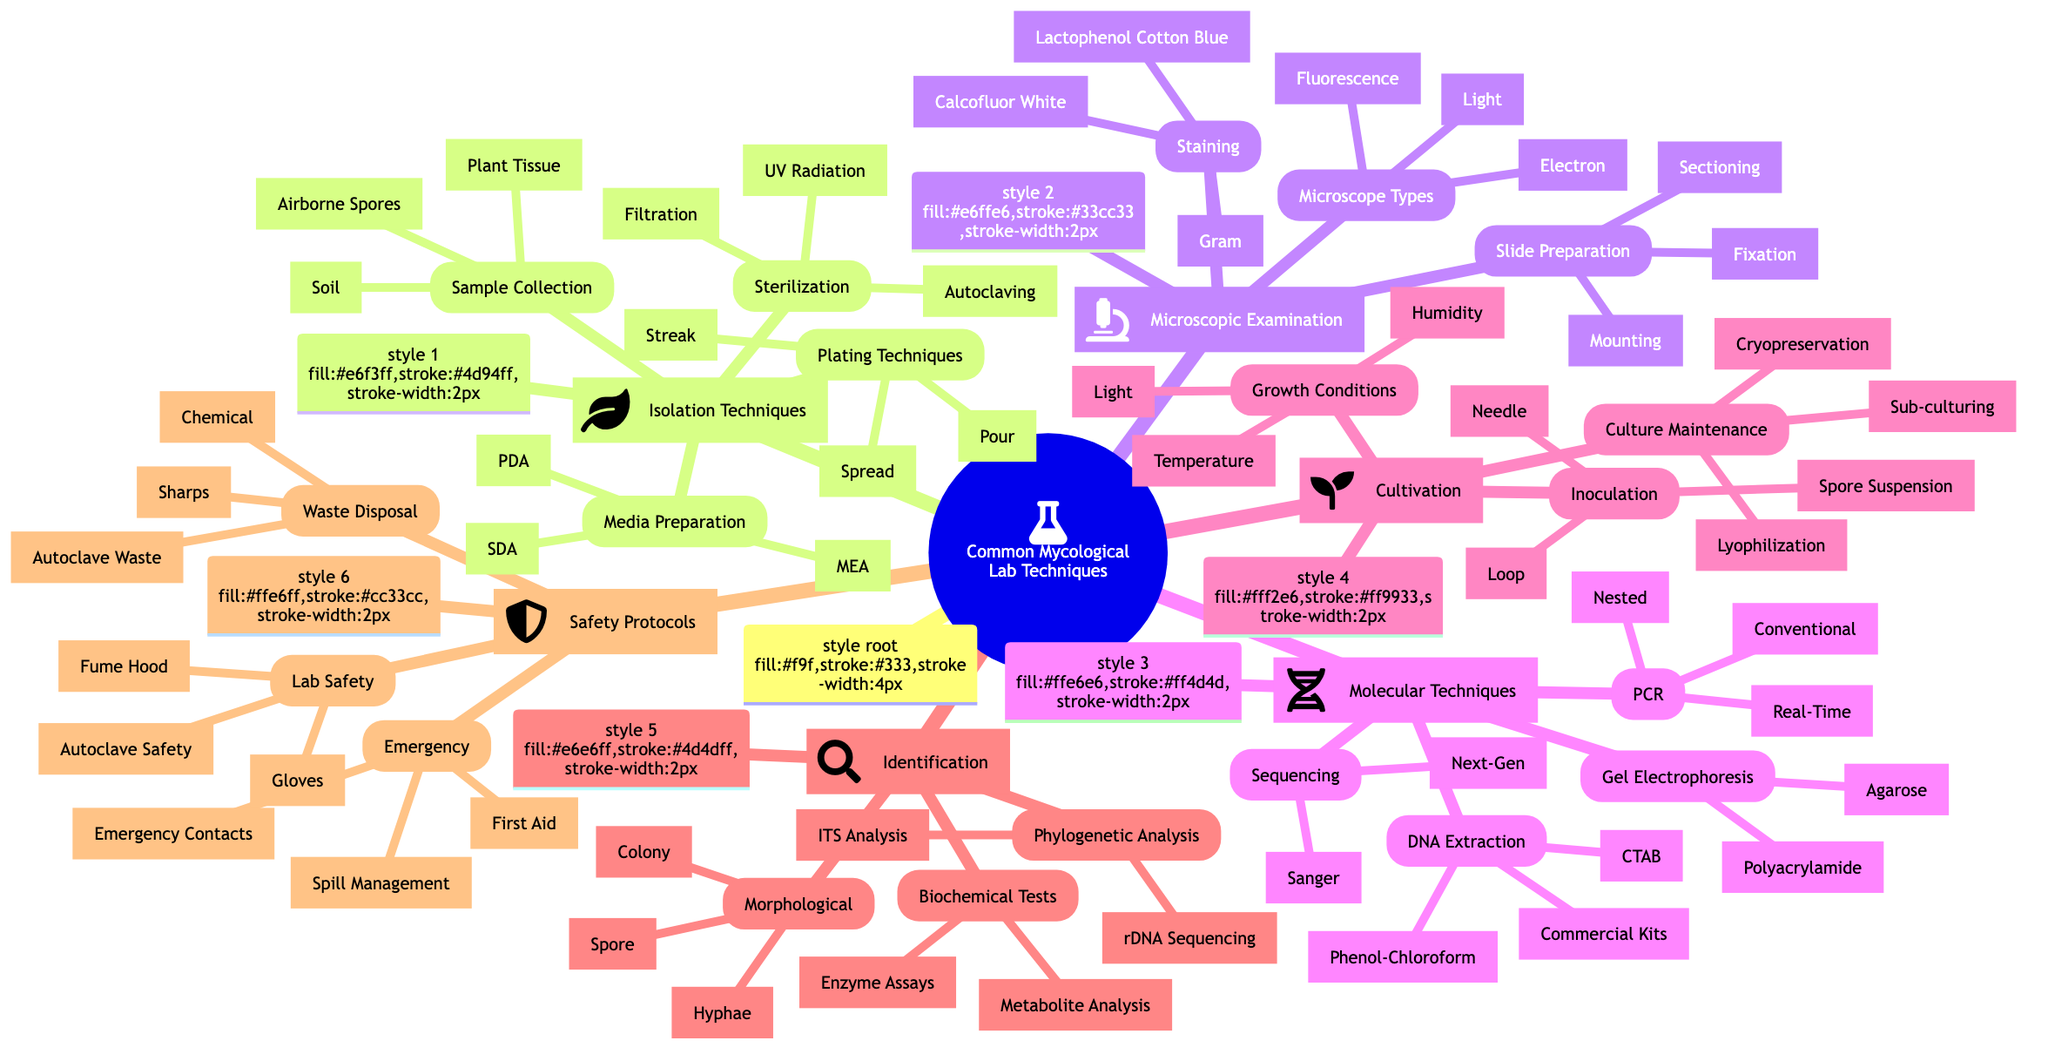What are the three types of isolation techniques listed? The diagram shows that "Isolation Techniques" includes four main categories: "Media Preparation," "Sterilization Methods," "Sample Collection," and "Plating Techniques." Among these, the first category, "Media Preparation," lists three specific media types: PDA, MEA, and SDA.
Answer: PDA, MEA, SDA How many methods are there for DNA extraction? In the "Molecular Techniques" section, under "DNA Extraction," there are three listed methods: CTAB Method, Phenol-Chloroform Method, and Commercial Kits. Therefore, the total number of methods is three.
Answer: 3 Which staining technique uses a blue dye? In the "Microscopic Examination" section, under "Staining Techniques," Lactophenol Cotton Blue is identified as the staining technique that uses blue dye. This can be directly referenced from that part of the diagram.
Answer: Lactophenol Cotton Blue What are the three microscope types mentioned? The diagram lists three types of microscopes within the "Microscopic Examination" section: the Light Microscope, Fluorescence Microscope, and Electron Microscope. Each microscope type is distinctly categorized, and all three are identified clearly in the structure.
Answer: Light Microscope, Fluorescence Microscope, Electron Microscope What is the main purpose of using autoclaving in mycological labs? Autoclaving appears under "Sterilization Methods" in the "Isolation Techniques" section. The primary purpose of autoclaving is to sterilize media and tools, ensuring no contamination during mycological experiments.
Answer: Sterilization Which techniques are listed under culture maintenance? The "Cultivation Techniques" section includes three methods for culture maintenance: Sub-culturing, Cryopreservation, and Lyophilization. This specific inquiry can direct a reader to that portion of the mind map for information.
Answer: Sub-culturing, Cryopreservation, Lyophilization How does the number of safety protocols compare to microscopic examination techniques? The "Safety Protocols" section has three main categories: Laboratory Safety, Waste Disposal, and Emergency Procedures, resulting in a total of nine safety protocols. The "Microscopic Examination" section has three categories: Staining Techniques, Microscope Types, and Slide Preparation, totaling nine as well. Both sections showcase an equal number of protocols.
Answer: 9 each Which inoculation method uses a needle? Within the "Cultivation Techniques" section, "Inoculation Methods" specifically lists "Needle Inoculation" as one of the methods, fulfilling this particular inquiry directly from the diagram.
Answer: Needle Inoculation 